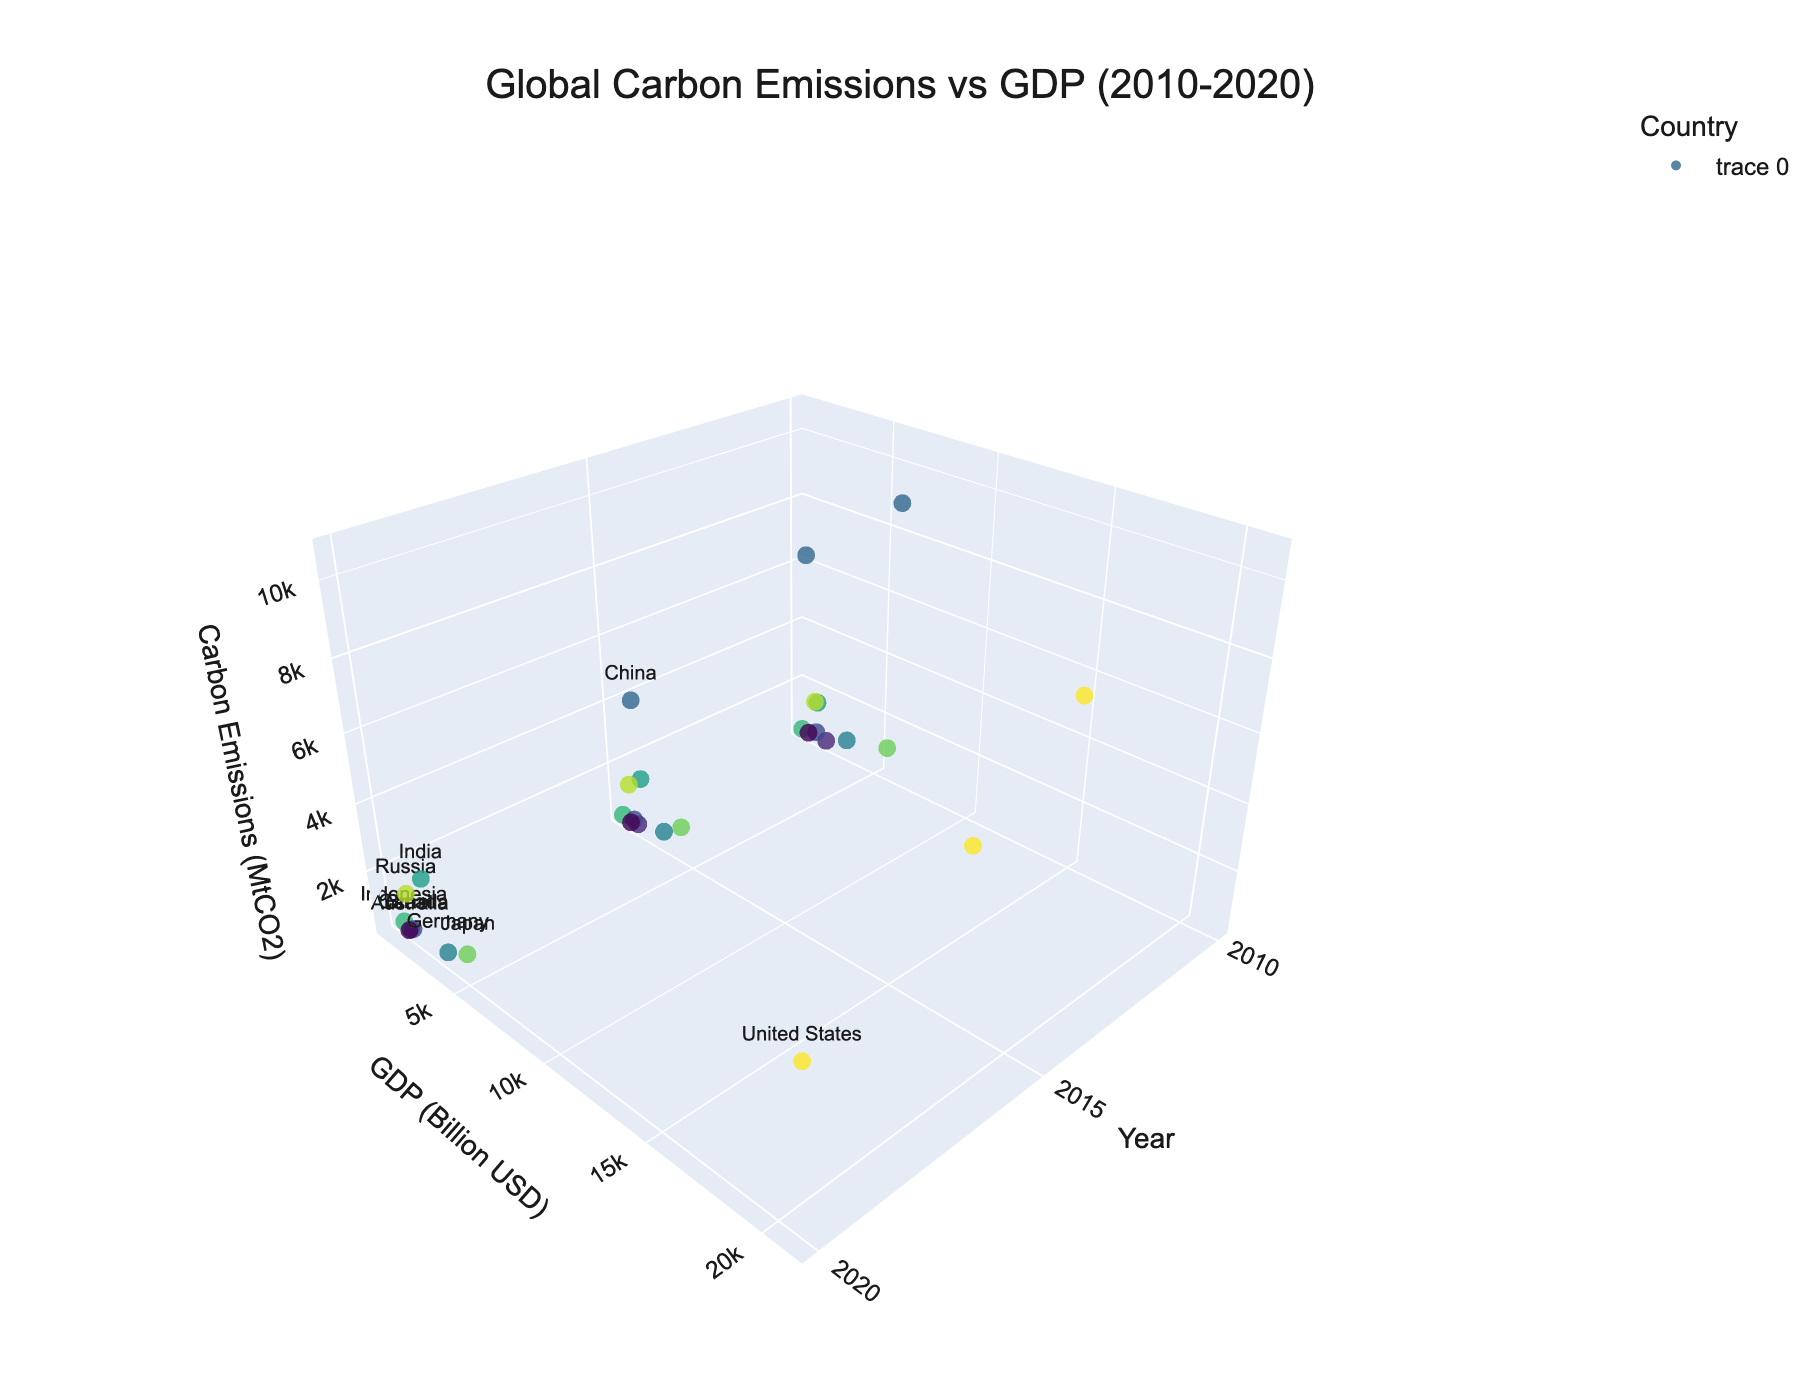What is the title of the plot? The title of the plot is displayed at the top of the figure. It provides a summary of what the figure represents. In this case, the title is "Global Carbon Emissions vs GDP (2010-2020)."
Answer: Global Carbon Emissions vs GDP (2010-2020) Which country had the highest carbon emissions in 2010? Locate the data points for the year 2010 on the x-axis. The countries with the highest carbon emissions are represented by the highest z-values. China has the highest carbon emissions in 2010.
Answer: China How did the GDP of the United States change from 2010 to 2020? Identify the data points for the United States in 2010 and 2020. Compare the y-values (GDP in Billion USD) for these two years. The GDP increased from 14992.1 billion USD in 2010 to 20932.8 billion USD in 2020.
Answer: It increased Which country had the lowest carbon emissions in 2020? Look at the data points for the year 2020 and identify the country with the lowest z-value. Australia had the lowest carbon emissions in 2020.
Answer: Australia What is the relationship between GDP and carbon emissions for China from 2010 to 2020? Analyze the data points representing China over the years 2010, 2015, and 2020. Both the GDP (y-axis) and carbon emissions (z-axis) generally increase over this period.
Answer: Both increase How does Japan's carbon emissions in 2020 compare to its emissions in 2015? Locate Japan's data points for the years 2015 and 2020. Compare the z-values to see the difference in carbon emissions. Emissions decreased from 1223.3 MtCO2 in 2015 to 1061.8 MtCO2 in 2020.
Answer: It decreased Which country has the highest GDP in 2020? Identify the data points for the year 2020 and find the country with the highest y-value (GDP in Billion USD). The United States has the highest GDP in 2020.
Answer: United States Did Russia's carbon emissions increase or decrease from 2010 to 2020? Identify Russia's data points for the years 2010 and 2020. Compare the z-values to determine the trend. Emissions decreased from 1613.5 MtCO2 in 2010 to 1577.1 MtCO2 in 2020.
Answer: It decreased What is the average GDP of Brazil over the years 2010, 2015, and 2020? Sum the y-values (GDP in Billion USD) for Brazil for the years 2010, 2015, and 2020, and then divide by the number of data points (3). (2208.9 + 1802.2 + 1444.7) / 3 = 1818.6 Billion USD
Answer: 1818.6 Billion USD Which country showed a significant increase in both GDP and carbon emissions from 2010 to 2015? Identify the countries and compare their data points for 2010 and 2015. China shows a significant increase in both GDP and carbon emissions from 2010 to 2015.
Answer: China 